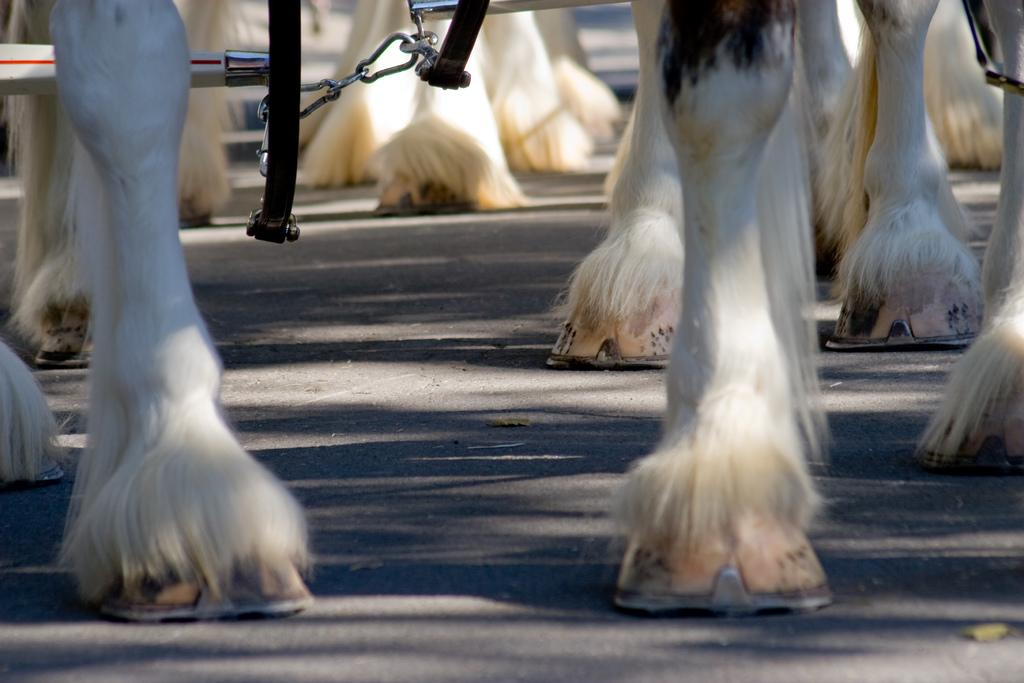What type of body parts are visible in the image? There are legs of animals in the image. What material are the rods made of in the image? The rods in the image are made of metal. Where is the stamp collection displayed in the image? There is no stamp collection present in the image. What type of industry can be seen operating in the image? There is no industry present in the image. 